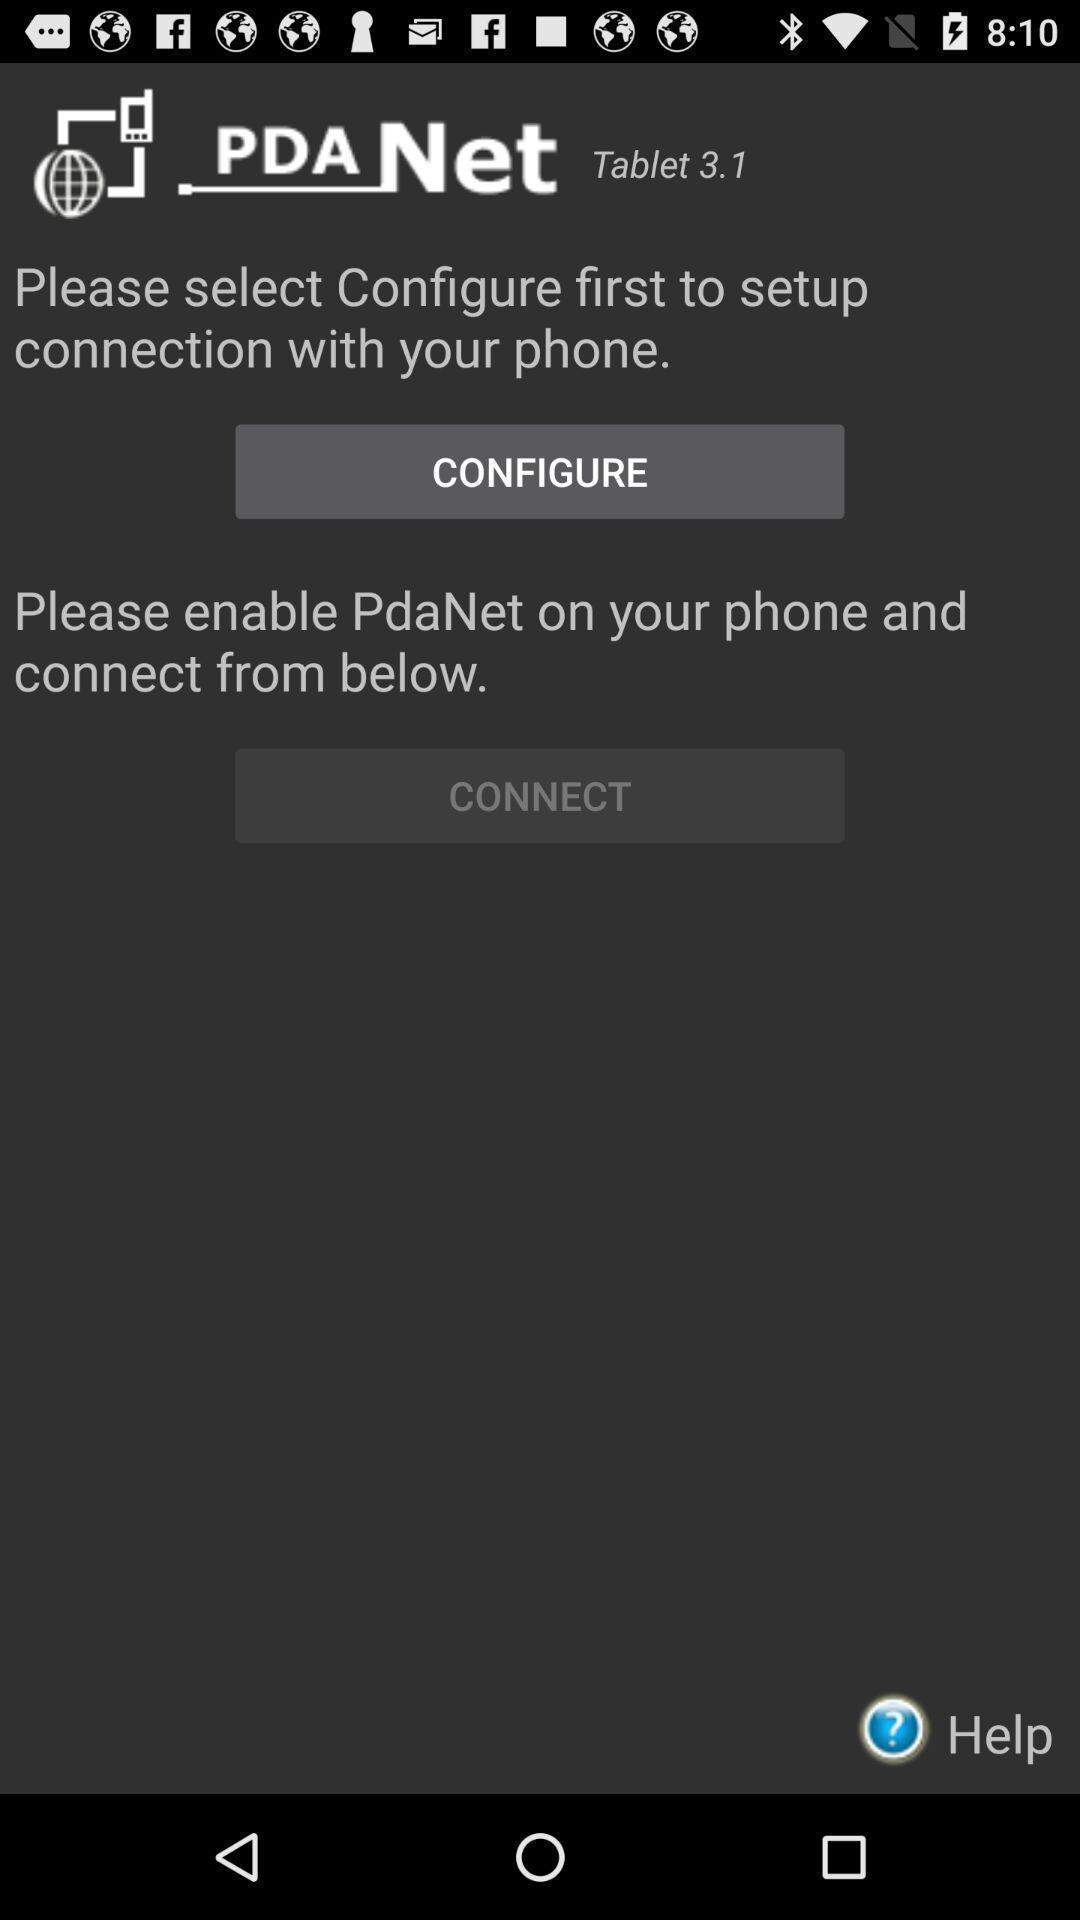Summarize the information in this screenshot. Screen displaying guide to setup connection settings. 